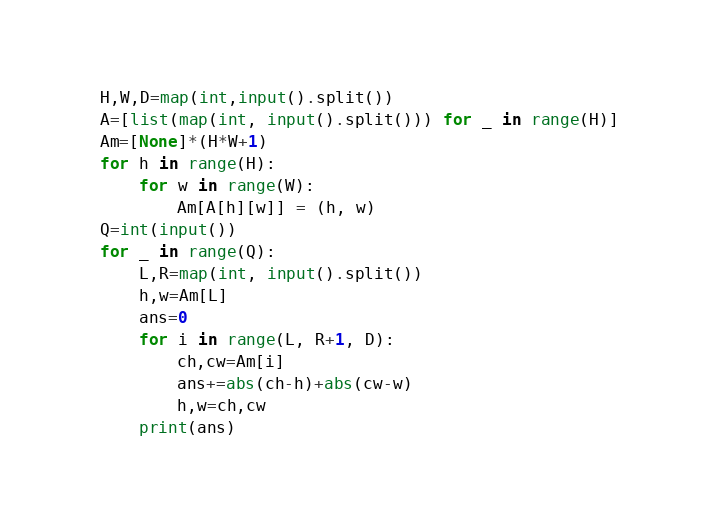<code> <loc_0><loc_0><loc_500><loc_500><_Python_>H,W,D=map(int,input().split())
A=[list(map(int, input().split())) for _ in range(H)]
Am=[None]*(H*W+1)
for h in range(H):
	for w in range(W):
		Am[A[h][w]] = (h, w)
Q=int(input())
for _ in range(Q):
	L,R=map(int, input().split())
	h,w=Am[L]
	ans=0
	for i in range(L, R+1, D):
		ch,cw=Am[i]
		ans+=abs(ch-h)+abs(cw-w)
		h,w=ch,cw
	print(ans)
</code> 